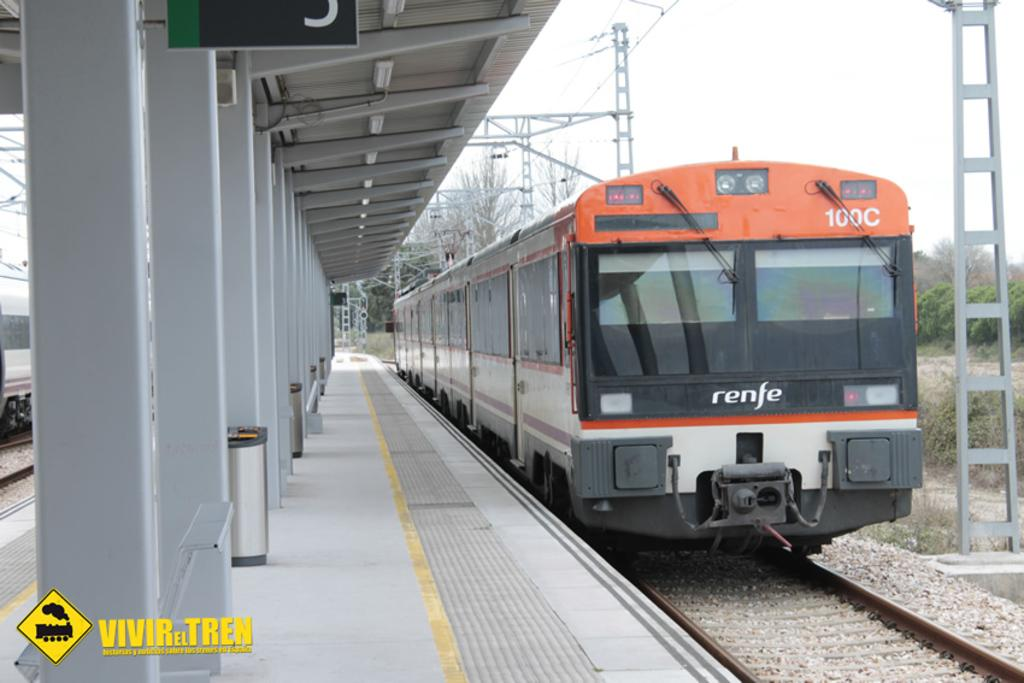What is the main subject of the image? The main subject of the image is a train on the track. What can be seen in the right corner of the image? There are poles and wires in the right corner of the image. What is located in the left corner of the image? There is a platform in the left corner of the image. What objects are present on the platform? The platform has dustbins and poles on it. Can you see a tramp performing on the platform in the image? No, there is no tramp performing on the platform in the image. What type of plate is being used by the passengers on the train? There is no plate visible in the image, as it focuses on the train, poles and wires, and the platform. 